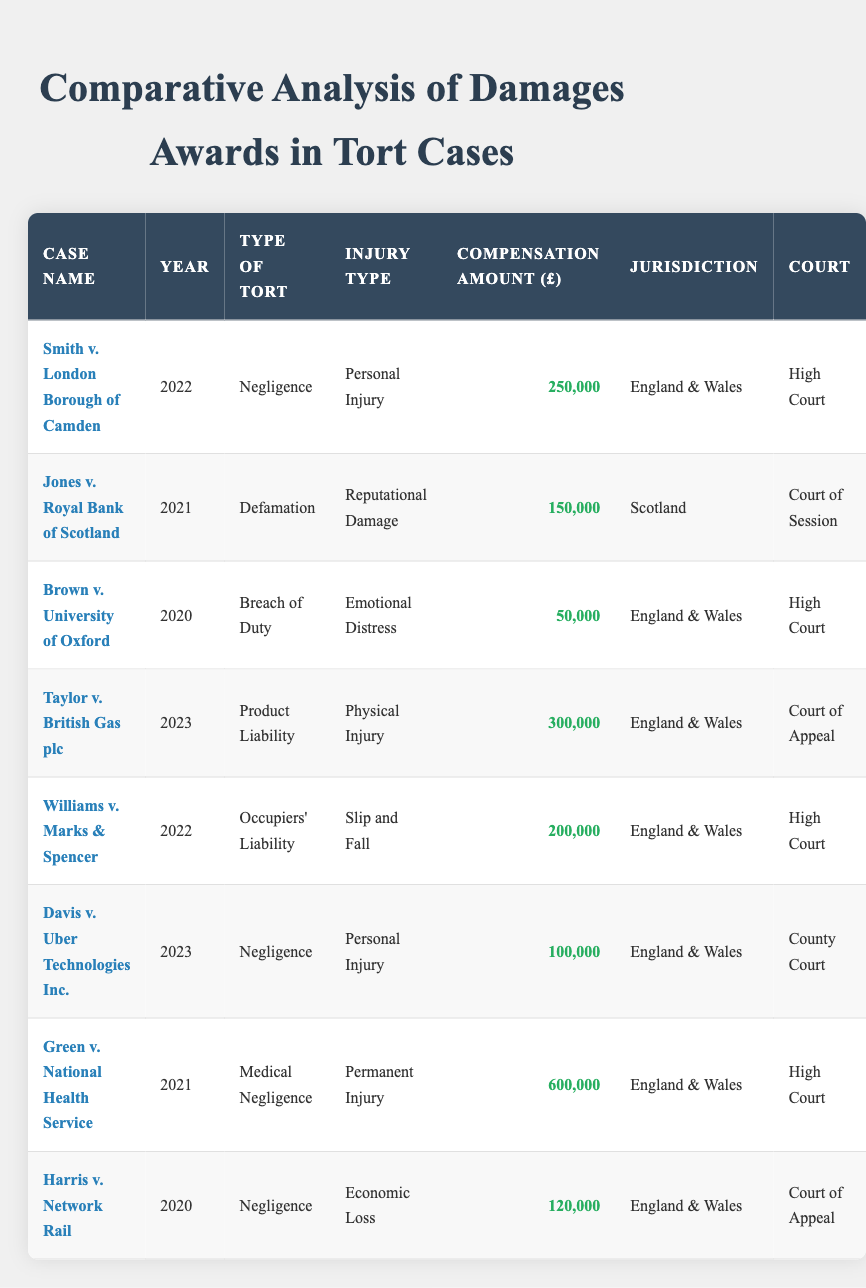What is the highest compensation amount awarded in the cases? The table indicates the compensation amounts for each case. By examining each amount, we see that the highest figure is £600,000, awarded in the case of Green v. National Health Service.
Answer: £600,000 How many cases were decided in 2022? In the table, we can count the number of rows corresponding to the year 2022. There are three cases, which are: Smith v. London Borough of Camden, Williams v. Marks & Spencer, and one more.
Answer: 3 Which case has the lowest compensation amount? Looking at the compensation amounts in the table, the lowest amount is £50,000, which is awarded in the case of Brown v. University of Oxford.
Answer: £50,000 What is the total compensation amount for negligence cases? By filtering out the negligence cases, we find the amounts for Smith v. London Borough of Camden (£250,000), Davis v. Uber Technologies Inc. (£100,000), and Harris v. Network Rail (£120,000). Summing these gives £250,000 + £100,000 + £120,000 = £470,000.
Answer: £470,000 Did any case involve economic loss? We can check the table to see if the injury type includes "Economic Loss." It does, as seen in Harris v. Network Rail, which validates the inquiry.
Answer: Yes Which jurisdiction had cases with a total compensation award of over £200,000? We examine the jurisdictions corresponding to compensation amounts over £200,000: England & Wales had Smith v. London Borough of Camden (£250,000) and Taylor v. British Gas plc (£300,000), leading to totals of £550,000 for this jurisdiction.
Answer: England & Wales What proportion of all awards were related to personal injury? From the table, we identify three cases related to personal injury (Smith v. London Borough of Camden, Davis v. Uber Technologies Inc., and Taylor v. British Gas plc). There are a total of eight cases overall. The proportion is calculated as 3/8 = 0.375 or 37.5%.
Answer: 37.5% Is there a case with a compensation amount exactly equal to £150,000? Checking through the compensation amounts, we find that Jones v. Royal Bank of Scotland has a compensation amount of exactly £150,000, confirming that this claim is true.
Answer: Yes 